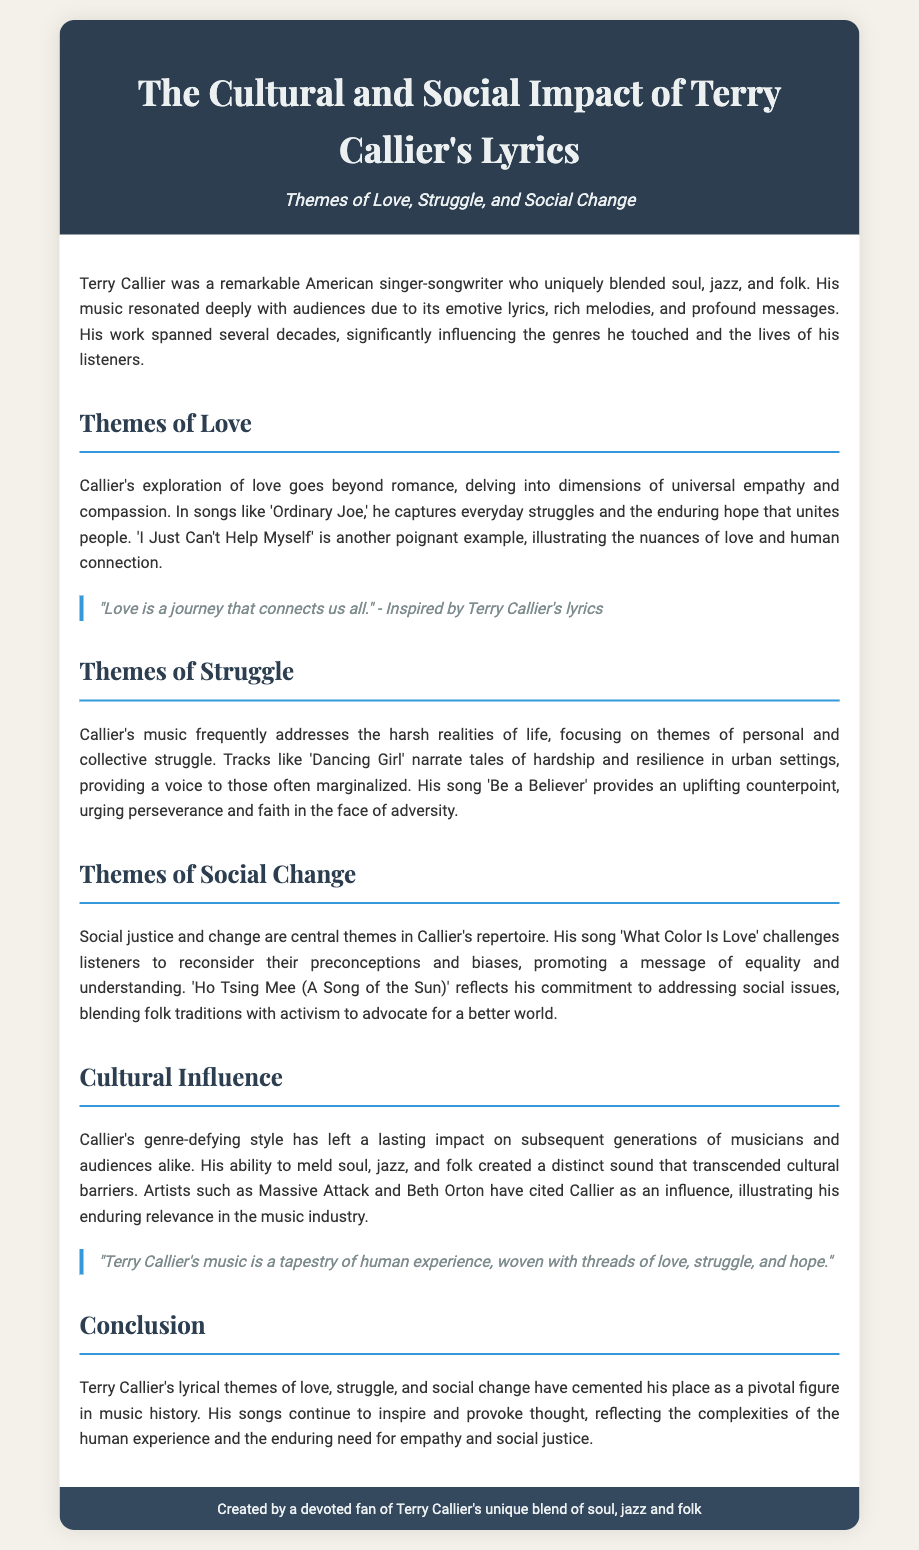What musical genres did Terry Callier blend? The document states that Terry Callier uniquely blended soul, jazz, and folk.
Answer: soul, jazz, and folk What is one of the themes explored in Callier's lyrics? The document lists themes such as love, struggle, and social change.
Answer: love Which song illustrates the nuances of love and human connection? The document mentions "I Just Can't Help Myself" as a poignant example.
Answer: I Just Can't Help Myself What song challenges listeners to reconsider their preconceptions? The document highlights "What Color Is Love" as a song promoting equality and understanding.
Answer: What Color Is Love Who cited Terry Callier as an influence? The document mentions artists like Massive Attack and Beth Orton acknowledging his influence.
Answer: Massive Attack and Beth Orton What does the song "Be a Believer" encourage? The document states that it urges perseverance and faith in the face of adversity.
Answer: perseverance and faith What is the cultural significance of Terry Callier's music? The document emphasizes that his genre-defying style has left a lasting impact on subsequent generations of musicians.
Answer: lasting impact In which decade did Terry Callier's work span? The document indicates that he worked significantly over several decades but does not specify a starting point; therefore it's implied to extend from the 1960s onwards.
Answer: several decades What is the concluding reflection on Callier's lyrics? The document mentions that his songs continue to inspire and provoke thought regarding empathy and social justice.
Answer: inspire and provoke thought 